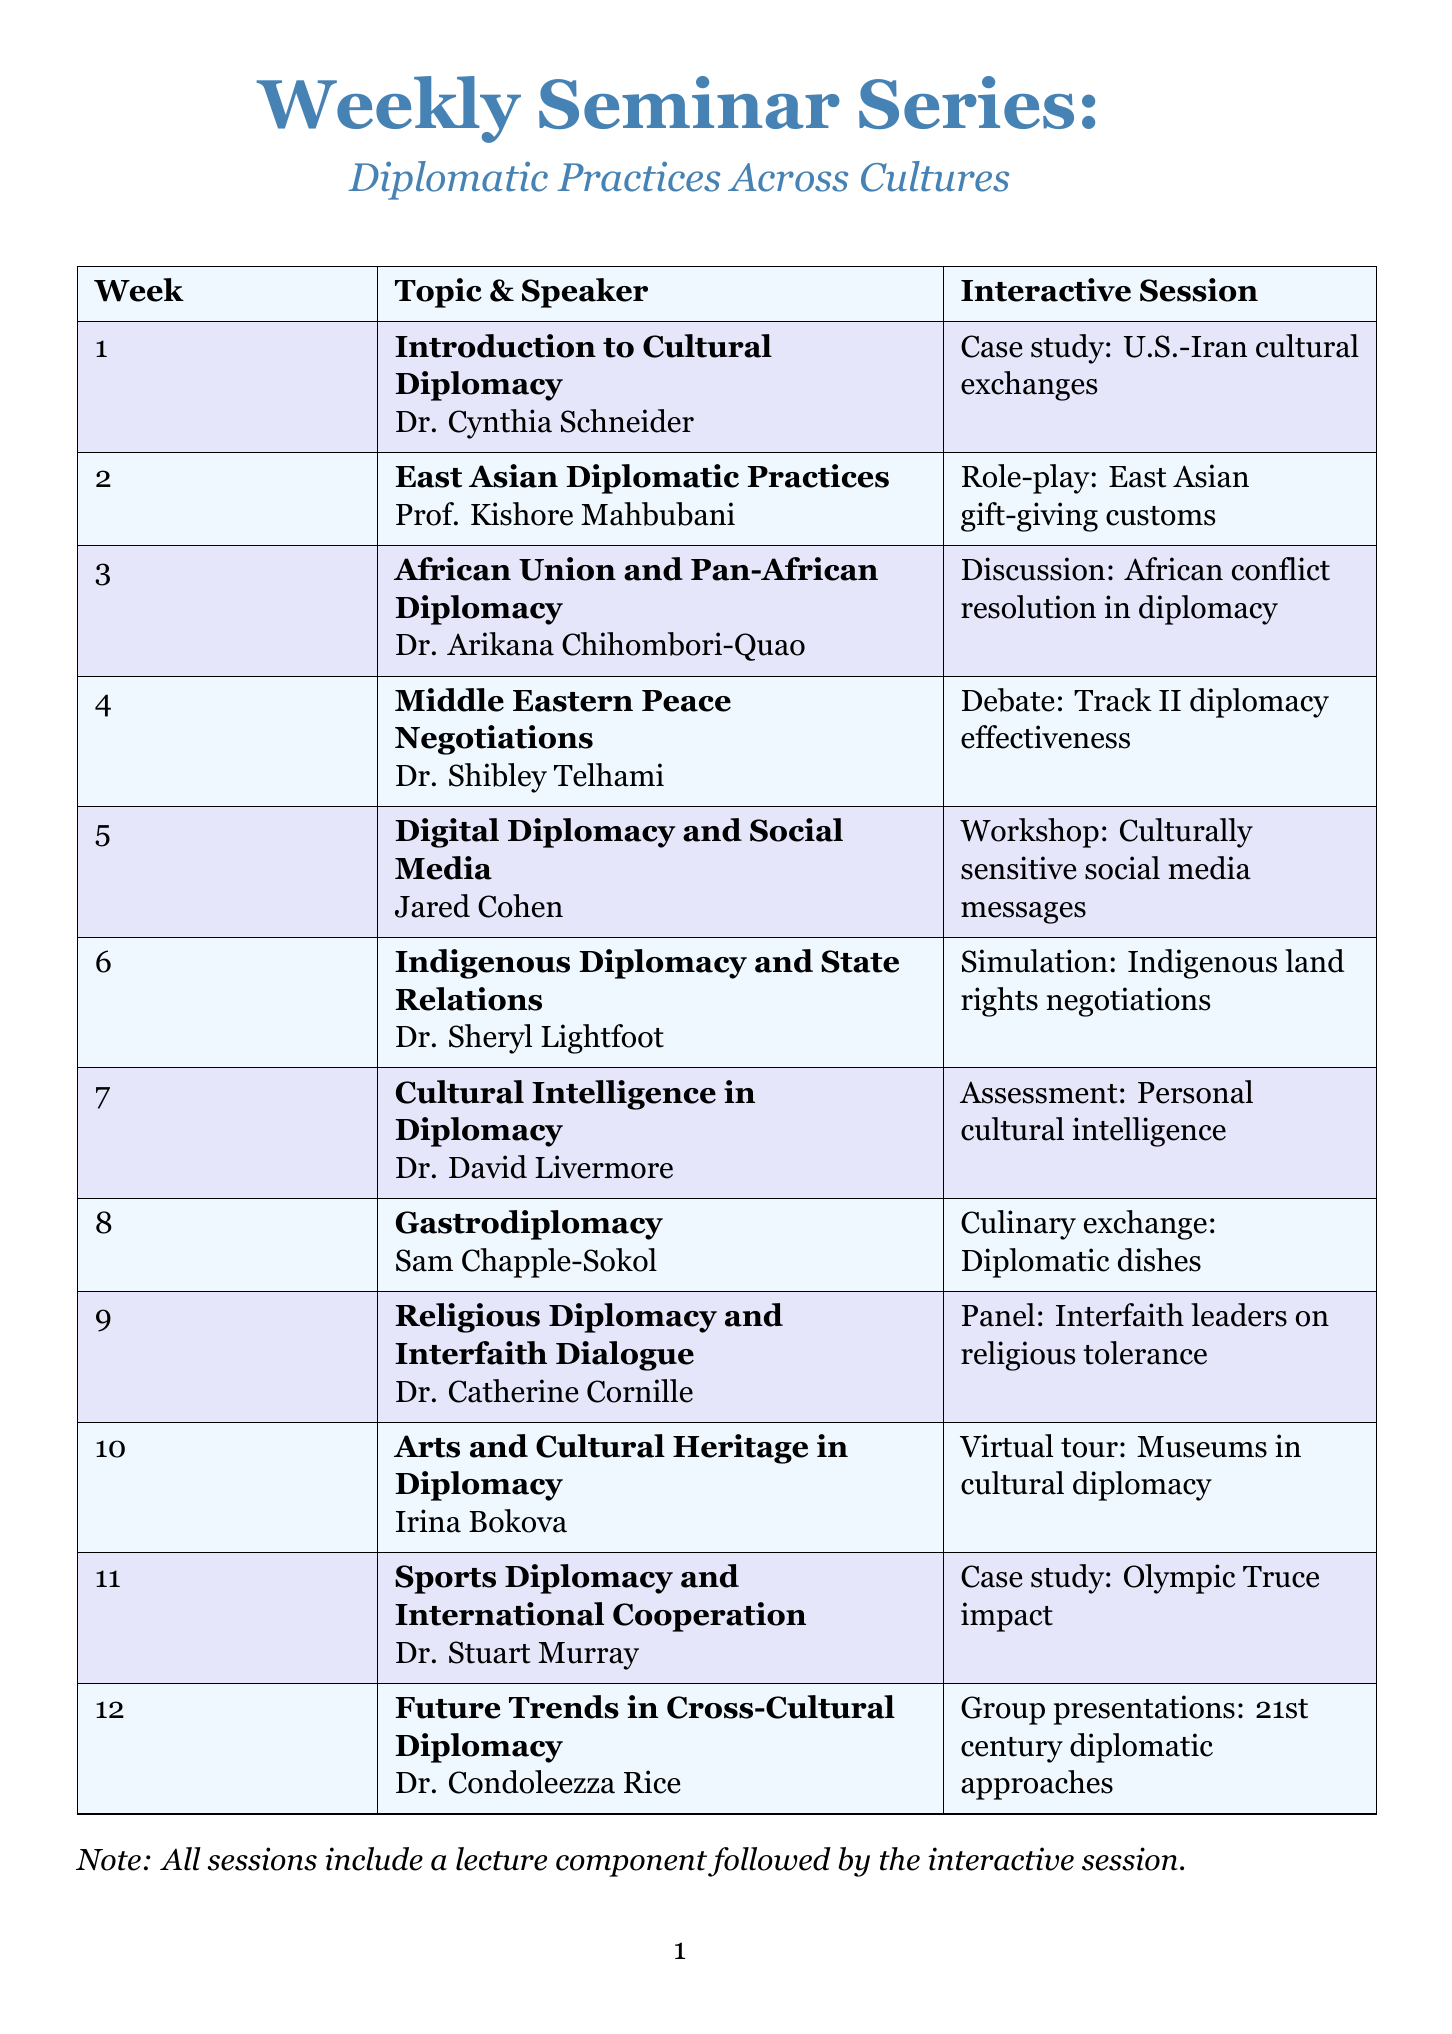What is the topic for week 1? The topic for week 1 is found in the seminar schedule under the first week section.
Answer: Introduction to Cultural Diplomacy Who is the speaker for week 5? The speaker for week 5 is listed alongside the topic in the schedule document.
Answer: Jared Cohen What type of interactive session is planned for week 3? The type of interactive session for week 3 is mentioned in the corresponding section of the schedule.
Answer: Group discussion How many weeks are in the seminar series? The total number of weeks is indicated by the number of entries in the seminar schedule.
Answer: 12 What is the focus of week 10's seminar? The focus of week 10 is described in the topic and speaker details in the document.
Answer: Arts and Cultural Heritage in Diplomacy Who examines Middle Eastern Peace Negotiations? The individual examining Middle Eastern Peace Negotiations is identified in the speaker section for week 4.
Answer: Dr. Shibley Telhami What is the interactive session in week 8? The interactive session for week 8 is specified in the schedule along with the week's topic.
Answer: Culinary exchange: Preparing and sharing dishes with diplomatic significance What is the title of the final session in week 12? The title of the final session can be found in the week 12 section of the seminar schedule.
Answer: Future Trends in Cross-Cultural Diplomacy Which speaker is associated with Indigenous Diplomacy? The speaker associated with Indigenous Diplomacy is identified in the document section for week 6.
Answer: Dr. Sheryl Lightfoot 